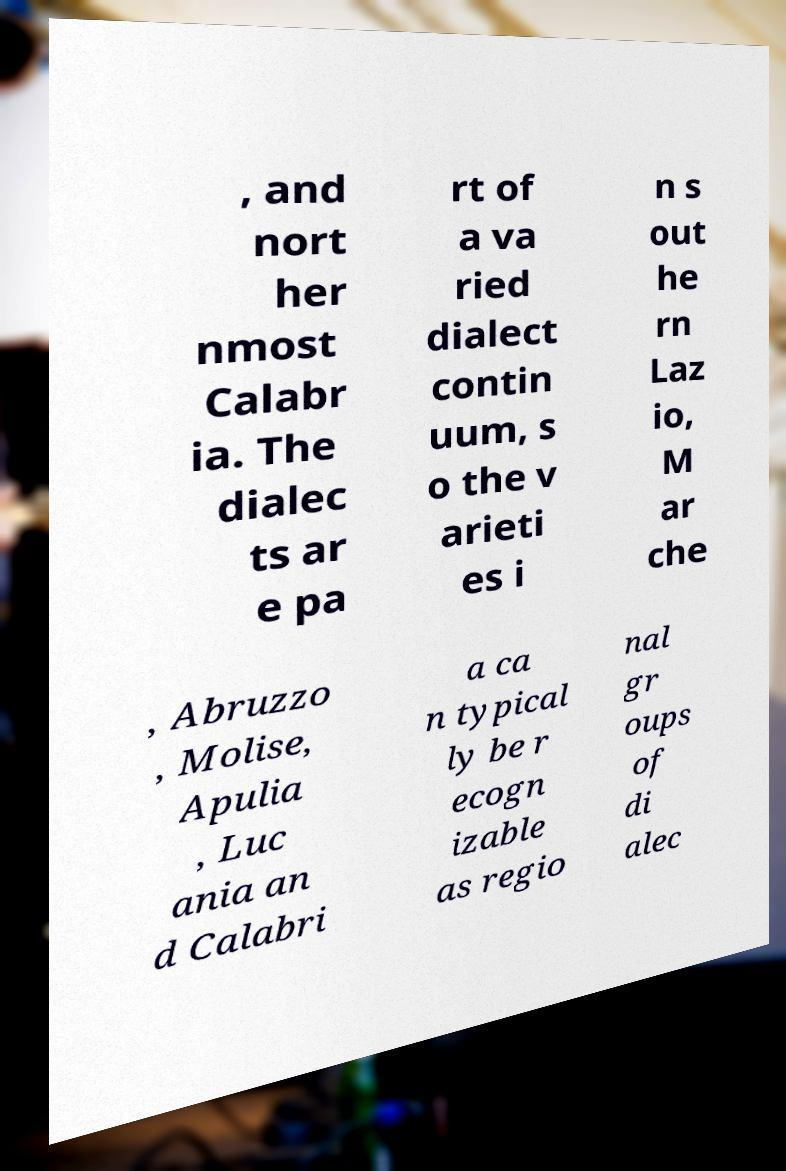Please identify and transcribe the text found in this image. , and nort her nmost Calabr ia. The dialec ts ar e pa rt of a va ried dialect contin uum, s o the v arieti es i n s out he rn Laz io, M ar che , Abruzzo , Molise, Apulia , Luc ania an d Calabri a ca n typical ly be r ecogn izable as regio nal gr oups of di alec 